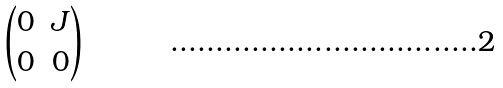Convert formula to latex. <formula><loc_0><loc_0><loc_500><loc_500>\begin{pmatrix} 0 & J \\ 0 & 0 \end{pmatrix}</formula> 